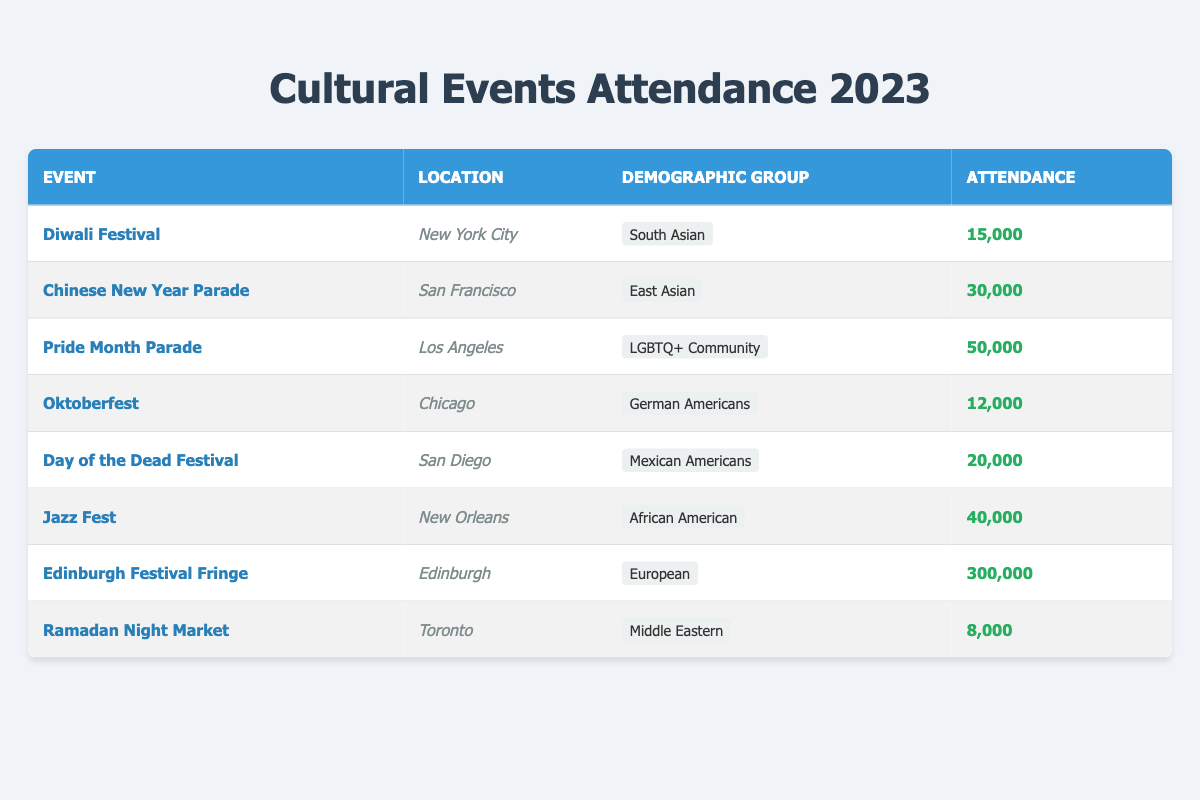What was the attendance for the Chinese New Year Parade in 2023? The attendance for the Chinese New Year Parade is listed in the table, specifically under the "Attendance" column corresponding to the row for that event. The number given is 30,000.
Answer: 30,000 Which event had the highest attendance? By reviewing the attendance numbers for each event in the table, we can identify the one with the highest value. The Edinburgh Festival Fringe has the highest attendance at 300,000.
Answer: Edinburgh Festival Fringe Was the attendance for the Diwali Festival more than 10,000? We look at the attendance number for the Diwali Festival, which is 15,000. Since 15,000 is greater than 10,000, the answer is yes.
Answer: Yes How many more attendees did the Pride Month Parade attract compared to the Oktoberfest? First, we find the attendance for each event: Pride Month Parade attracted 50,000 attendees, while Oktoberfest had 12,000. To find the difference, we subtract: 50,000 - 12,000 = 38,000.
Answer: 38,000 What is the total attendance for events representing Middle Eastern and South Asian demographic groups? We first locate the attendances for both groups: the Ramadan Night Market has 8,000 attendees, and the Diwali Festival has 15,000 attendees. Adding these together gives us: 8,000 + 15,000 = 23,000.
Answer: 23,000 Is the attendance for Oktoberfest less than that for the Day of the Dead Festival? The attendance for Oktoberfest is 12,000 and for the Day of the Dead Festival is 20,000. Since 12,000 is less than 20,000, the answer is yes.
Answer: Yes Which demographic group had the lowest attendance at their cultural event? We review the attendance figures for each demographic group. The Ramadan Night Market has the lowest attendance at 8,000, which is confirmed by comparing all values in the attendance column.
Answer: Middle Eastern 